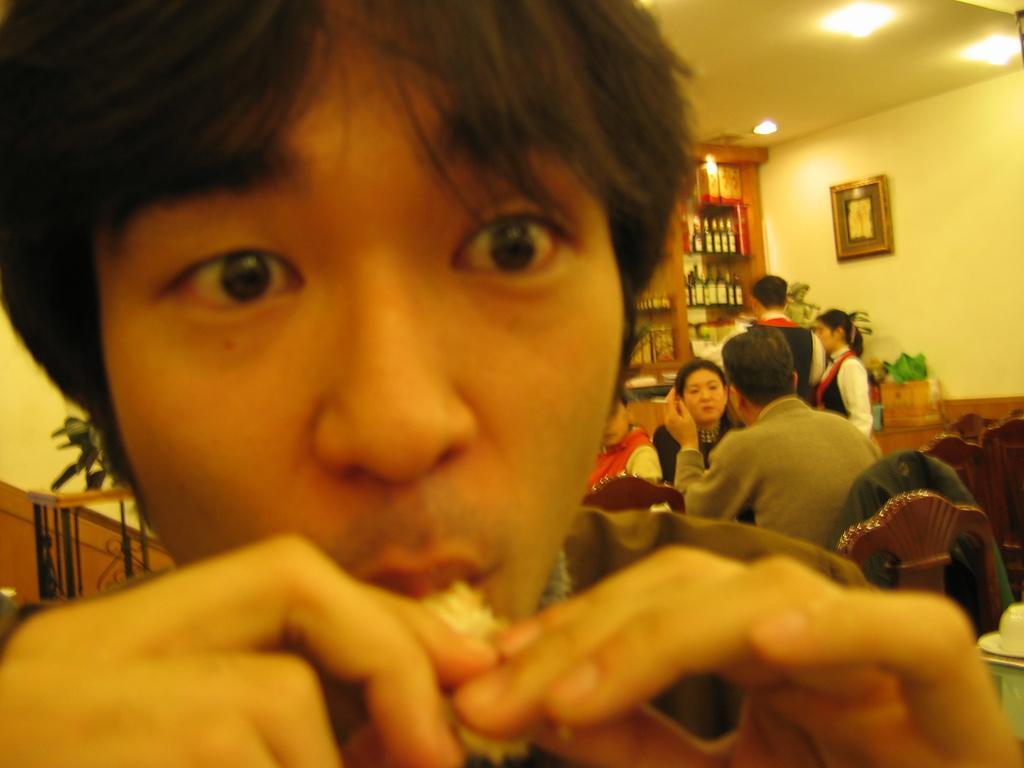Describe this image in one or two sentences. In this image I see a man over here who is holding a thing which is in his mouth and in the background I see few people in which these 3 of them are sitting and these both are standing and I see number of bottles in these racks and I see a frame on this wall and I see the lights on the ceiling. 